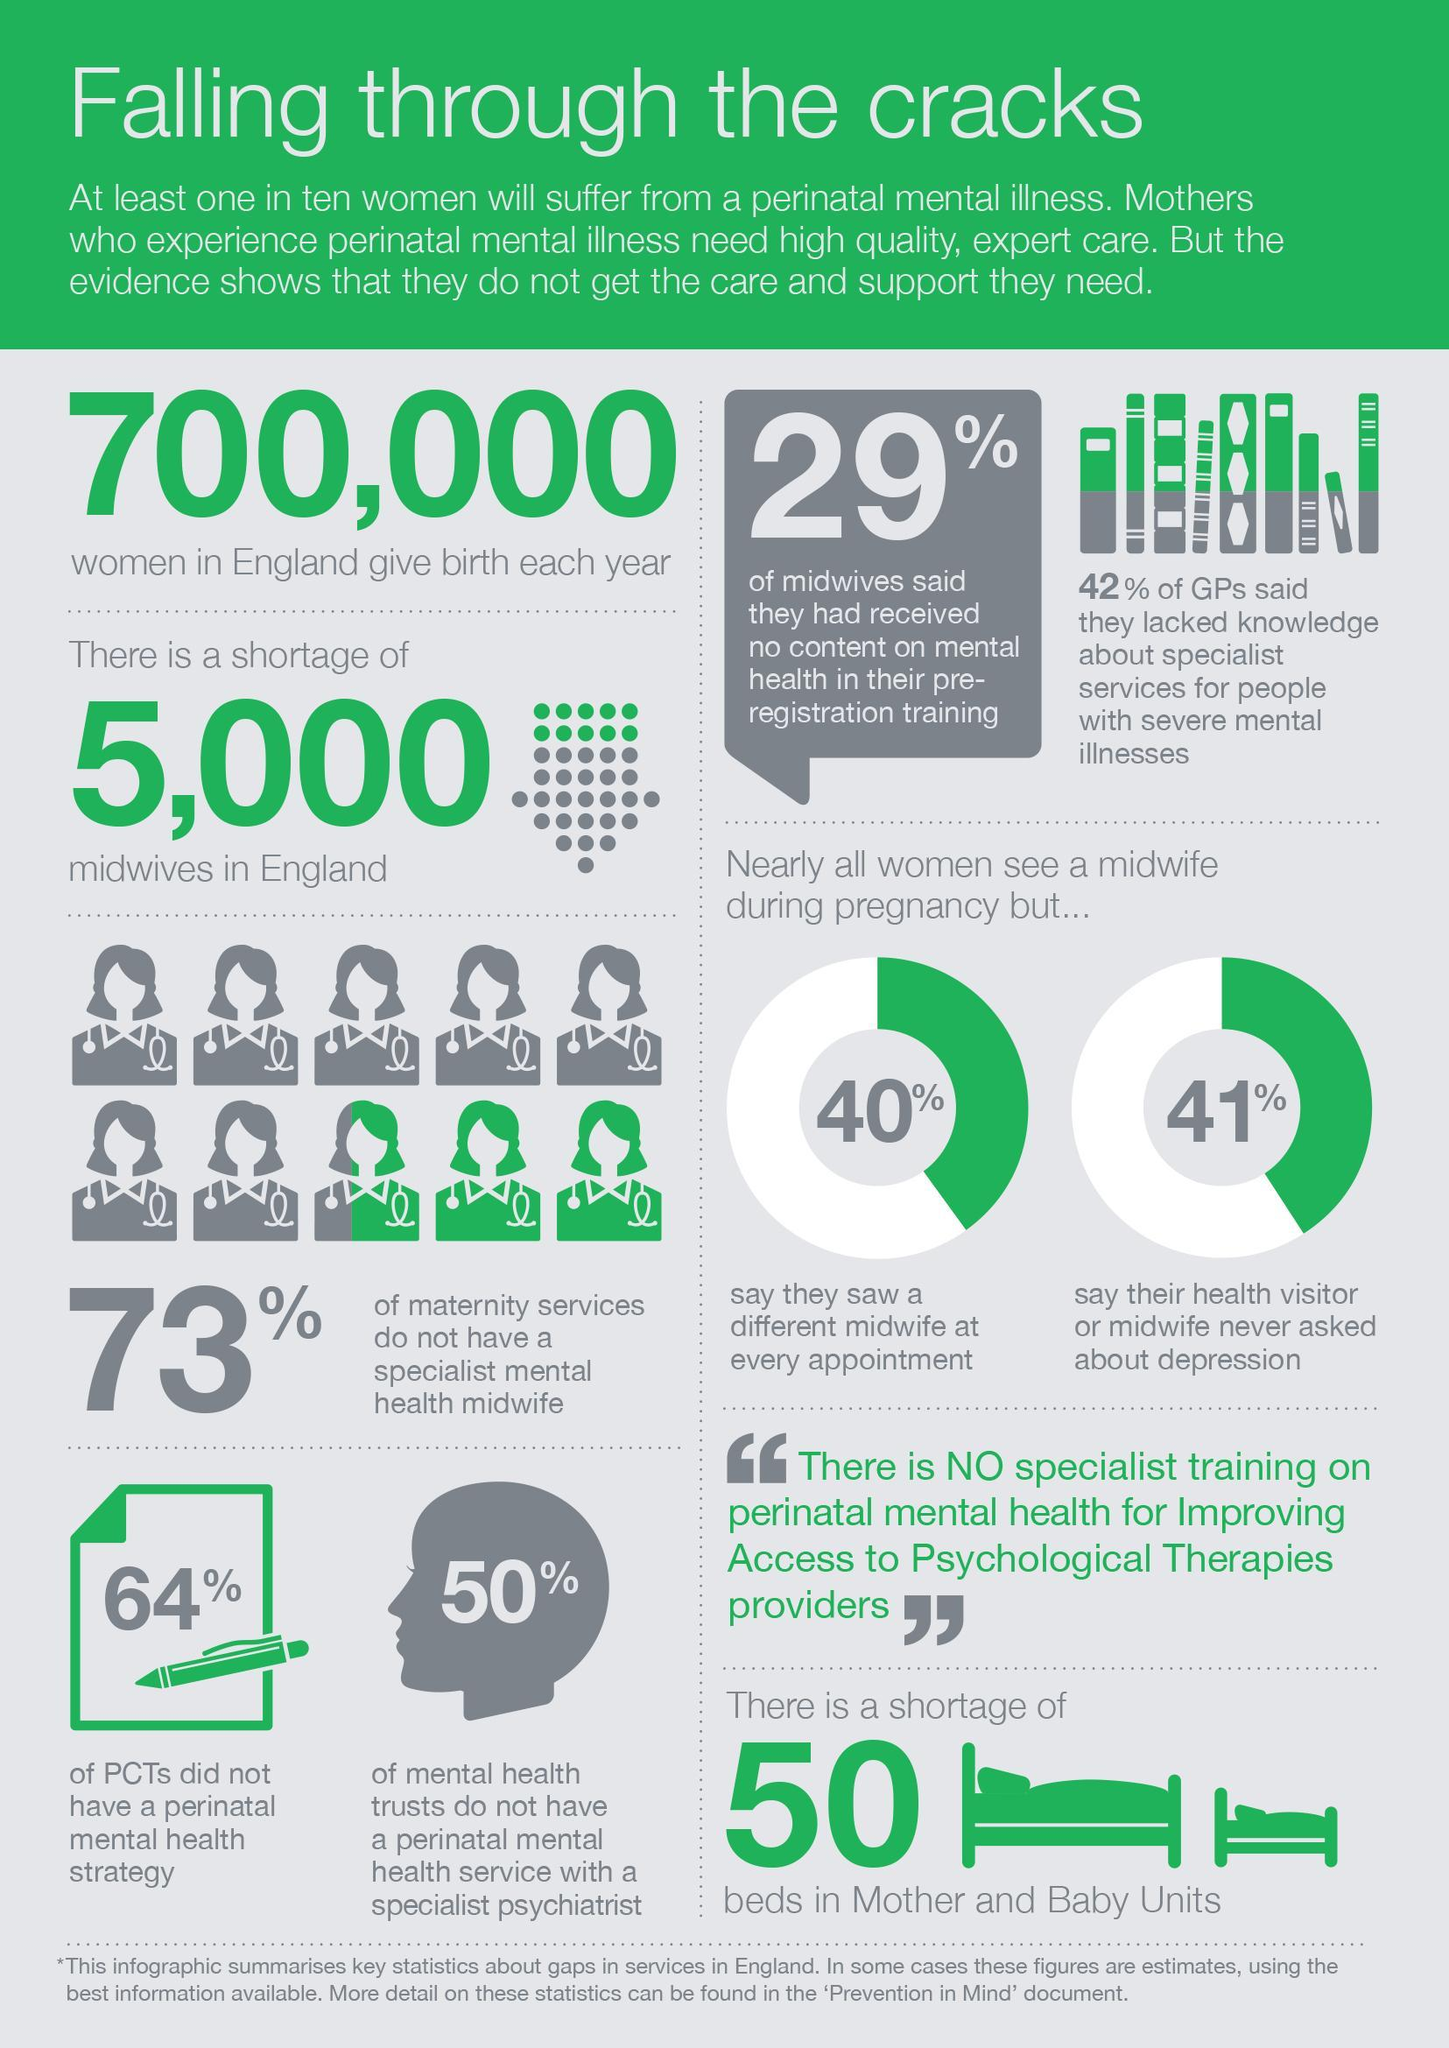What percentage of mental health trusts have a perinatal mental health service with a specialist psychiatrist?
Answer the question with a short phrase. 50% What percentage of maternity services have a specialist mental health midwife? 27% What percentage of PCTs have a perinatal mental health strategy? 36% 